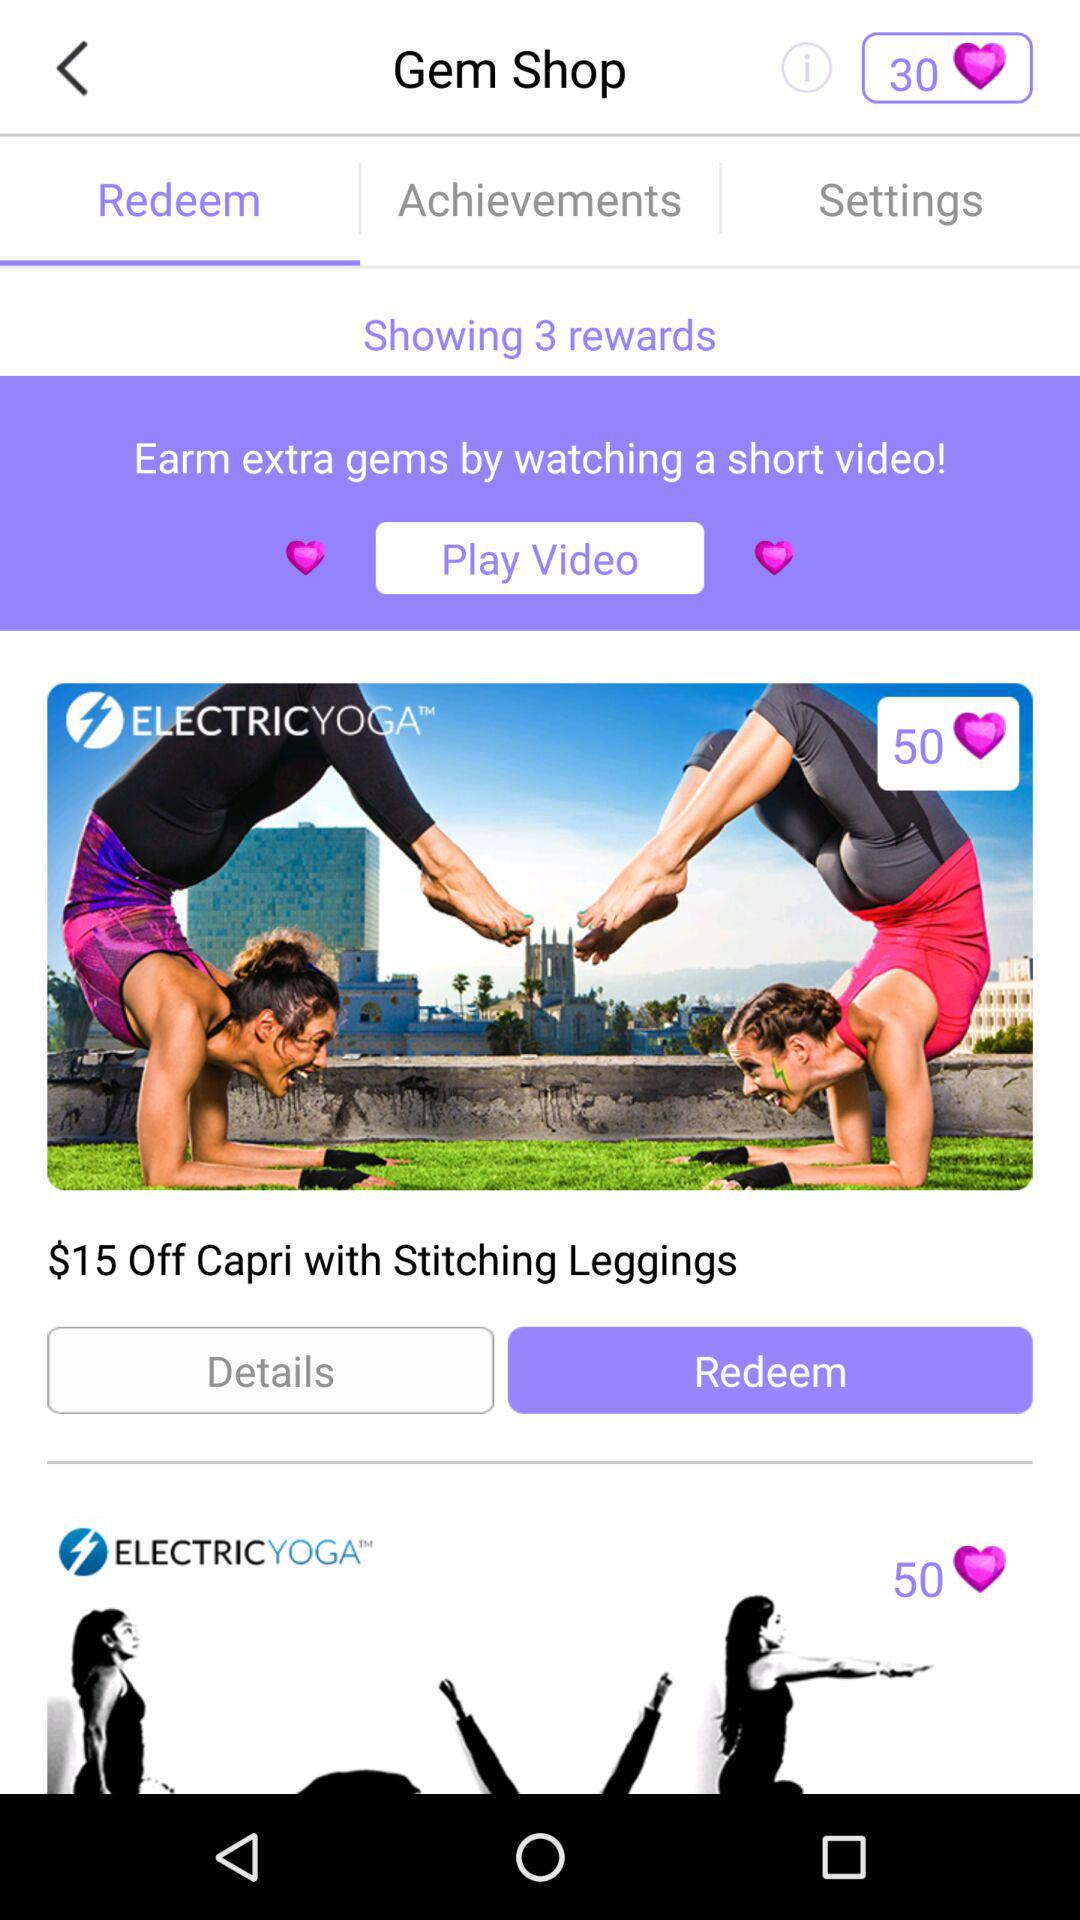How many rewards are shown? There are 3 rewards. 